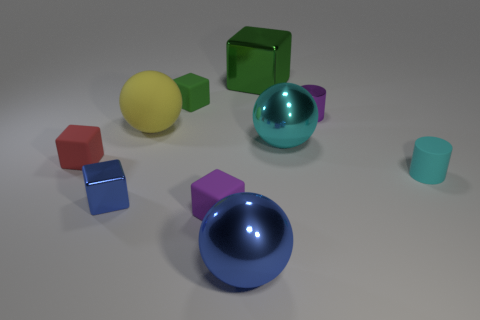What is the size of the cyan ball that is the same material as the blue sphere?
Your response must be concise. Large. Is the shape of the tiny blue shiny thing the same as the red matte thing?
Your answer should be compact. Yes. What color is the shiny block that is the same size as the yellow matte thing?
Make the answer very short. Green. What is the size of the purple matte thing that is the same shape as the green rubber object?
Your answer should be very brief. Small. What shape is the purple thing in front of the small cyan matte cylinder?
Ensure brevity in your answer.  Cube. Is the shape of the purple matte object the same as the cyan thing that is behind the tiny cyan object?
Keep it short and to the point. No. Is the number of large yellow rubber things that are right of the cyan rubber object the same as the number of balls left of the big yellow rubber object?
Your answer should be compact. Yes. What shape is the object that is the same color as the matte cylinder?
Your answer should be very brief. Sphere. There is a ball to the right of the large green cube; is it the same color as the large metallic ball in front of the large cyan sphere?
Offer a terse response. No. Is the number of objects behind the yellow sphere greater than the number of blue cubes?
Offer a very short reply. Yes. 